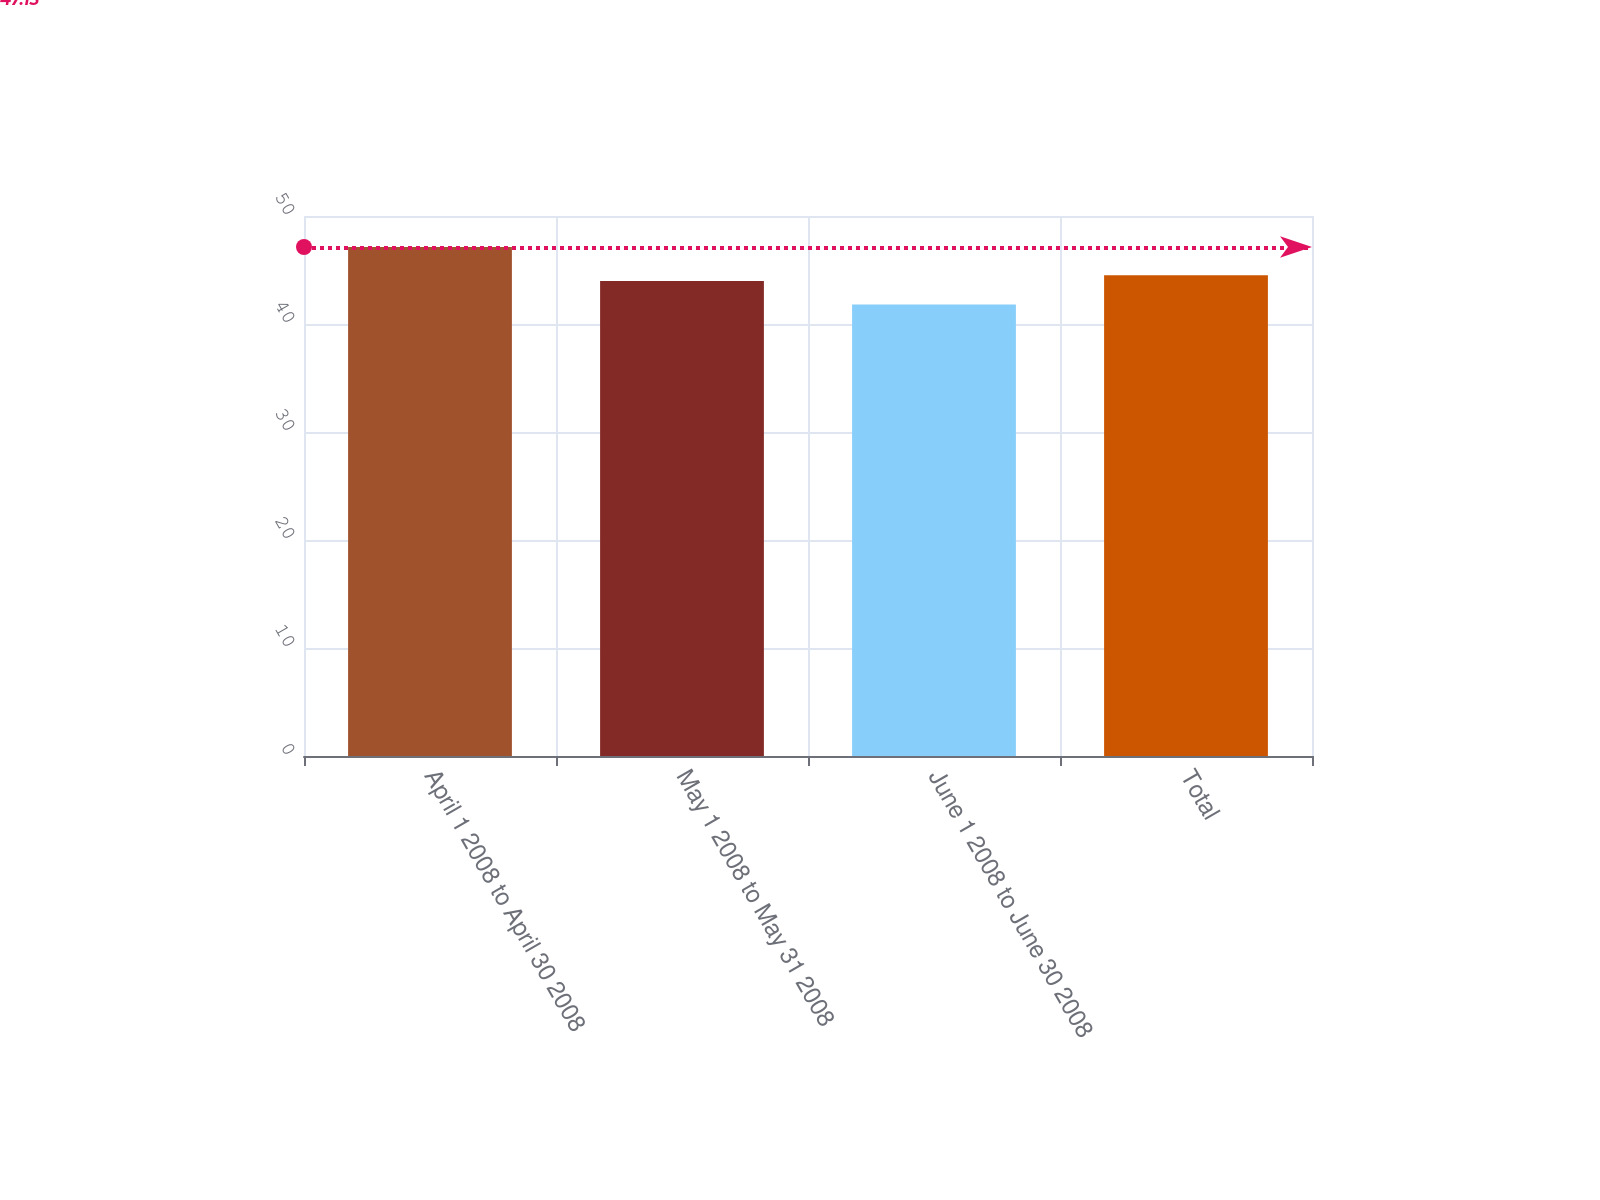Convert chart. <chart><loc_0><loc_0><loc_500><loc_500><bar_chart><fcel>April 1 2008 to April 30 2008<fcel>May 1 2008 to May 31 2008<fcel>June 1 2008 to June 30 2008<fcel>Total<nl><fcel>47.13<fcel>43.99<fcel>41.8<fcel>44.52<nl></chart> 